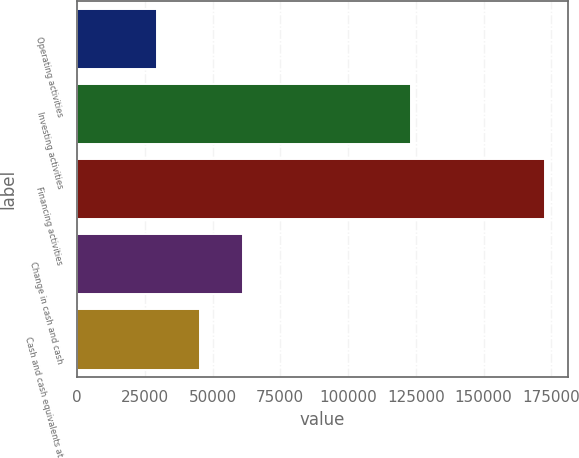Convert chart to OTSL. <chart><loc_0><loc_0><loc_500><loc_500><bar_chart><fcel>Operating activities<fcel>Investing activities<fcel>Financing activities<fcel>Change in cash and cash<fcel>Cash and cash equivalents at<nl><fcel>29498.5<fcel>123130<fcel>172540<fcel>61285.5<fcel>45392<nl></chart> 